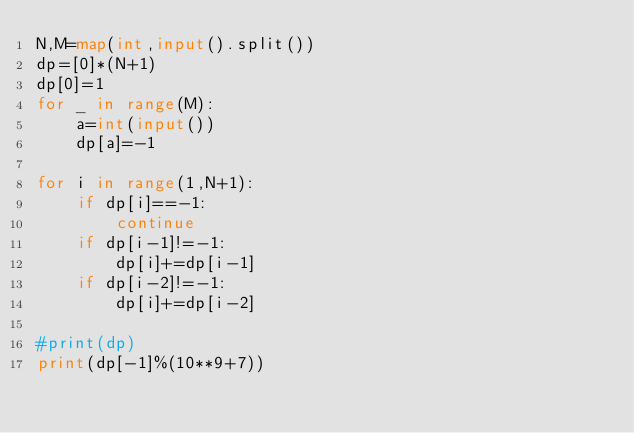<code> <loc_0><loc_0><loc_500><loc_500><_Python_>N,M=map(int,input().split())
dp=[0]*(N+1)
dp[0]=1
for _ in range(M):
    a=int(input())
    dp[a]=-1

for i in range(1,N+1):
    if dp[i]==-1:
        continue
    if dp[i-1]!=-1:
        dp[i]+=dp[i-1]
    if dp[i-2]!=-1:
        dp[i]+=dp[i-2]

#print(dp)
print(dp[-1]%(10**9+7))
</code> 